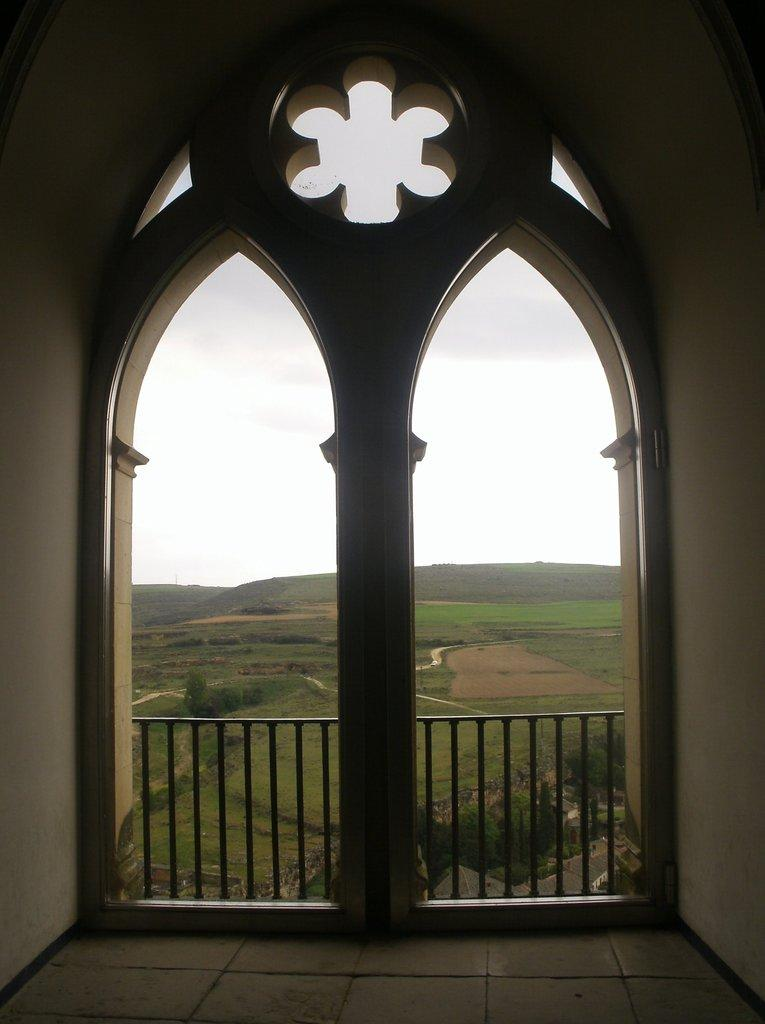What type of structure is present in the image? There is a building in the image. What type of barrier is present near the building? There is metal railing in the image. What type of vegetation is present in the image? There are trees in the image. What type of ground cover is present in the image? There is grass on the ground in the image. What can be seen in the distance in the image? There are mountains visible in the background of the image. What else is visible in the background of the image? The sky is visible in the background of the image. How many books can be seen on the grass in the image? There are no books present in the image; it features a building, metal railing, trees, grass, mountains, and the sky. How does the dime balance on the metal railing in the image? There is no dime present in the image, so it cannot be balanced on the metal railing. 